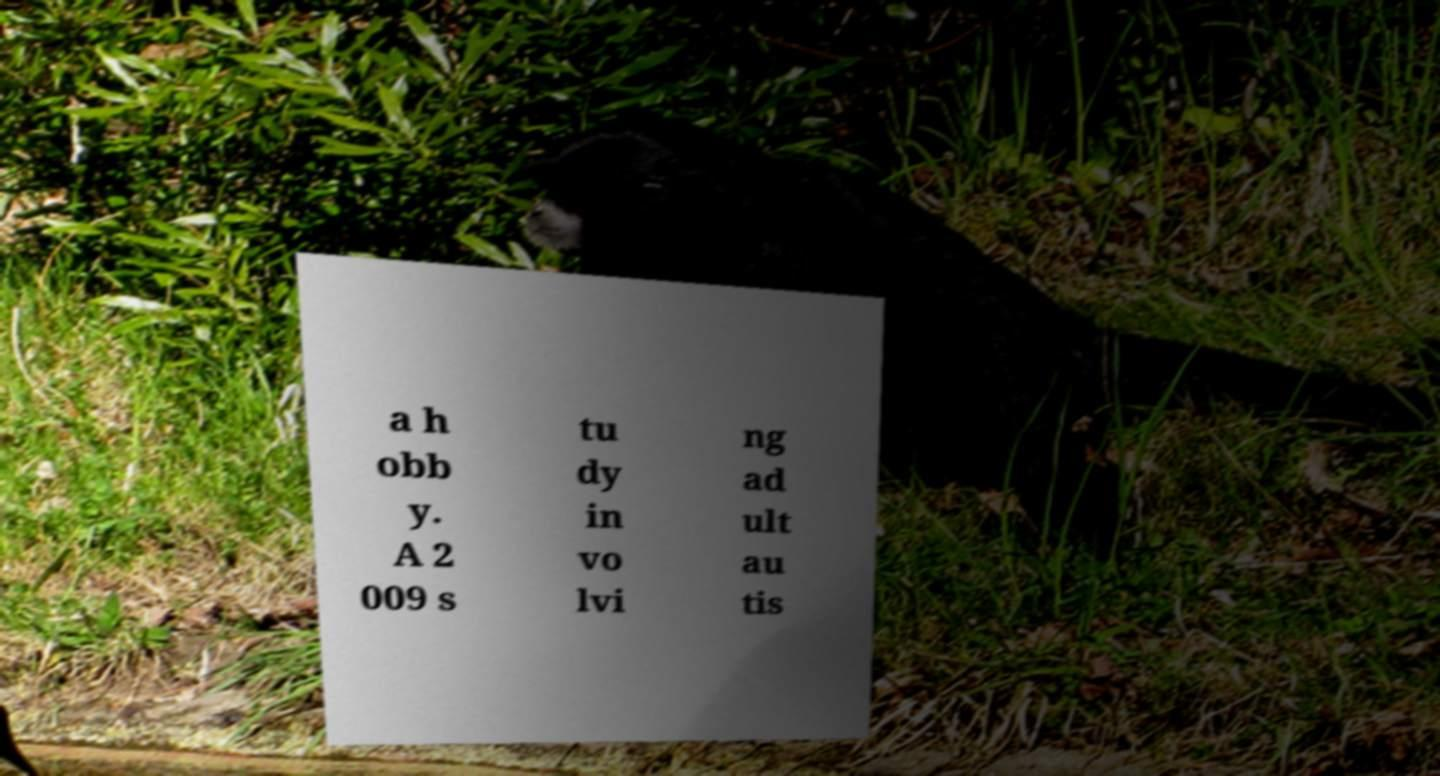Please read and relay the text visible in this image. What does it say? a h obb y. A 2 009 s tu dy in vo lvi ng ad ult au tis 